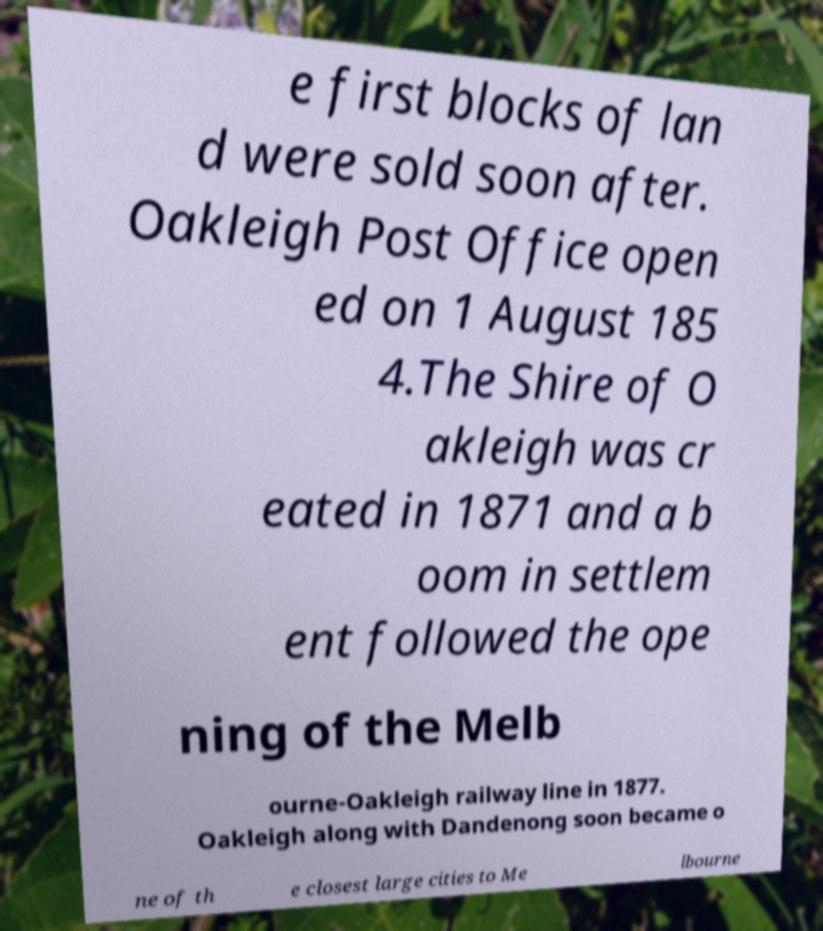Can you read and provide the text displayed in the image?This photo seems to have some interesting text. Can you extract and type it out for me? e first blocks of lan d were sold soon after. Oakleigh Post Office open ed on 1 August 185 4.The Shire of O akleigh was cr eated in 1871 and a b oom in settlem ent followed the ope ning of the Melb ourne-Oakleigh railway line in 1877. Oakleigh along with Dandenong soon became o ne of th e closest large cities to Me lbourne 